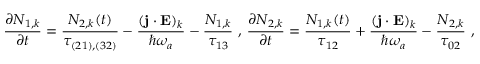Convert formula to latex. <formula><loc_0><loc_0><loc_500><loc_500>\frac { \partial N _ { 1 , k } } { \partial t } = \frac { N _ { 2 , k } ( t ) } { \tau _ { ( 2 1 ) , ( 3 2 ) } } - \frac { ( j \cdot E ) _ { k } } { \hbar { \omega } _ { a } } - \frac { N _ { 1 , k } } { \tau _ { 1 3 } } , \frac { \partial N _ { 2 , k } } { \partial t } = \frac { N _ { 1 , k } ( t ) } { \tau _ { 1 2 } } + \frac { ( j \cdot E ) _ { k } } { \hbar { \omega } _ { a } } - \frac { N _ { 2 , k } } { \tau _ { 0 2 } } ,</formula> 